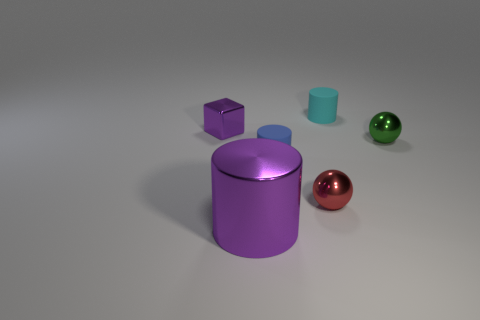Subtract all big metal cylinders. How many cylinders are left? 2 Add 3 gray matte cylinders. How many objects exist? 9 Add 6 green shiny spheres. How many green shiny spheres are left? 7 Add 6 tiny green shiny things. How many tiny green shiny things exist? 7 Subtract 0 brown blocks. How many objects are left? 6 Subtract all cubes. How many objects are left? 5 Subtract all green cylinders. Subtract all brown spheres. How many cylinders are left? 3 Subtract all small red things. Subtract all metallic balls. How many objects are left? 3 